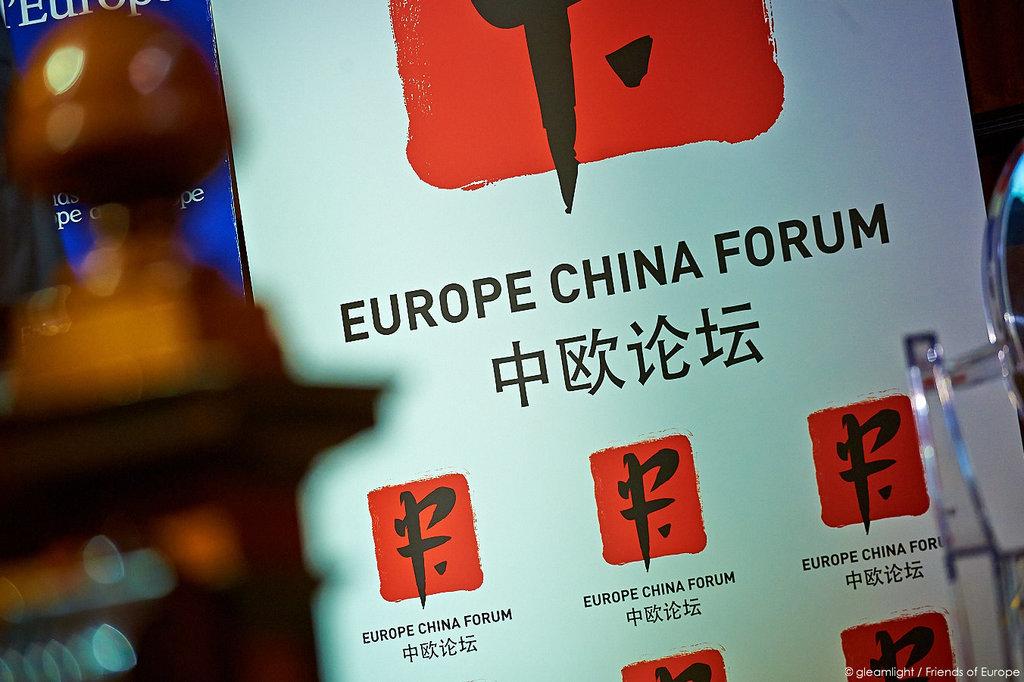What forum is this?
Your response must be concise. Europe china forum. 